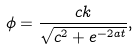<formula> <loc_0><loc_0><loc_500><loc_500>\phi = \frac { c k } { \sqrt { c ^ { 2 } + e ^ { - 2 a t } } } ,</formula> 